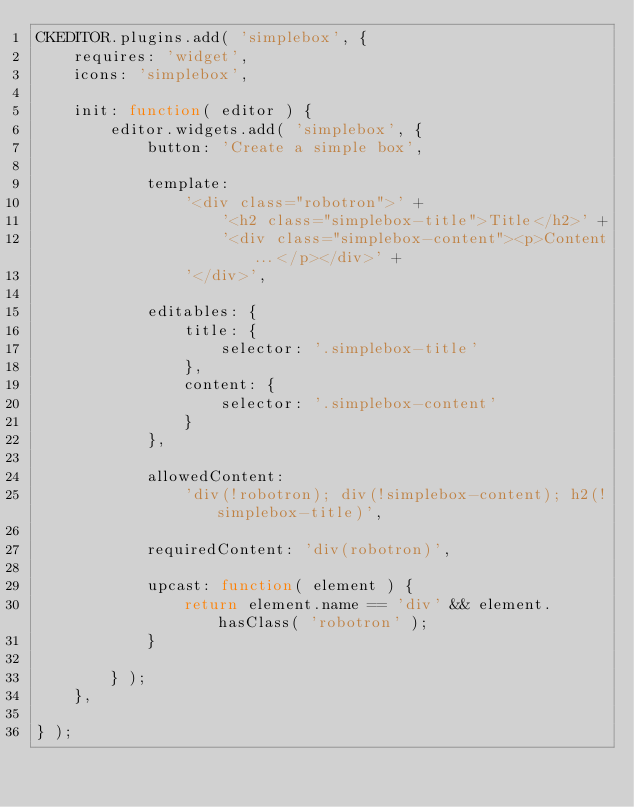Convert code to text. <code><loc_0><loc_0><loc_500><loc_500><_JavaScript_>CKEDITOR.plugins.add( 'simplebox', {
    requires: 'widget',
    icons: 'simplebox',

    init: function( editor ) {
        editor.widgets.add( 'simplebox', {
            button: 'Create a simple box',

            template: 
                '<div class="robotron">' +
                    '<h2 class="simplebox-title">Title</h2>' +
                    '<div class="simplebox-content"><p>Content...</p></div>' +
                '</div>',
        
            editables: {
                title: {
                    selector: '.simplebox-title'
                },
                content: {
                    selector: '.simplebox-content'
                }
            },
            
            allowedContent:
                'div(!robotron); div(!simplebox-content); h2(!simplebox-title)',
        
            requiredContent: 'div(robotron)',
            
            upcast: function( element ) {
                return element.name == 'div' && element.hasClass( 'robotron' );
            }
        
        } );
    },

} );
</code> 